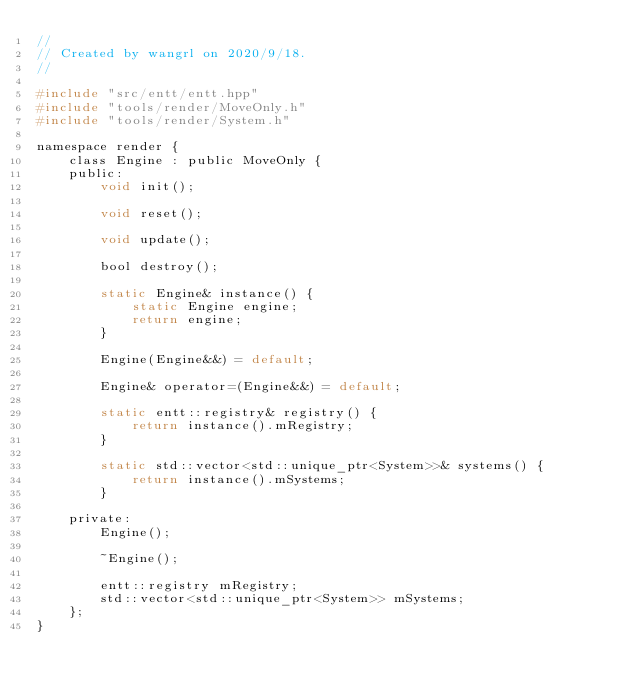<code> <loc_0><loc_0><loc_500><loc_500><_C_>//
// Created by wangrl on 2020/9/18.
//

#include "src/entt/entt.hpp"
#include "tools/render/MoveOnly.h"
#include "tools/render/System.h"

namespace render {
    class Engine : public MoveOnly {
    public:
        void init();

        void reset();

        void update();

        bool destroy();

        static Engine& instance() {
            static Engine engine;
            return engine;
        }

        Engine(Engine&&) = default;

        Engine& operator=(Engine&&) = default;

        static entt::registry& registry() {
            return instance().mRegistry;
        }

        static std::vector<std::unique_ptr<System>>& systems() {
            return instance().mSystems;
        }

    private:
        Engine();

        ~Engine();

        entt::registry mRegistry;
        std::vector<std::unique_ptr<System>> mSystems;
    };
}
</code> 